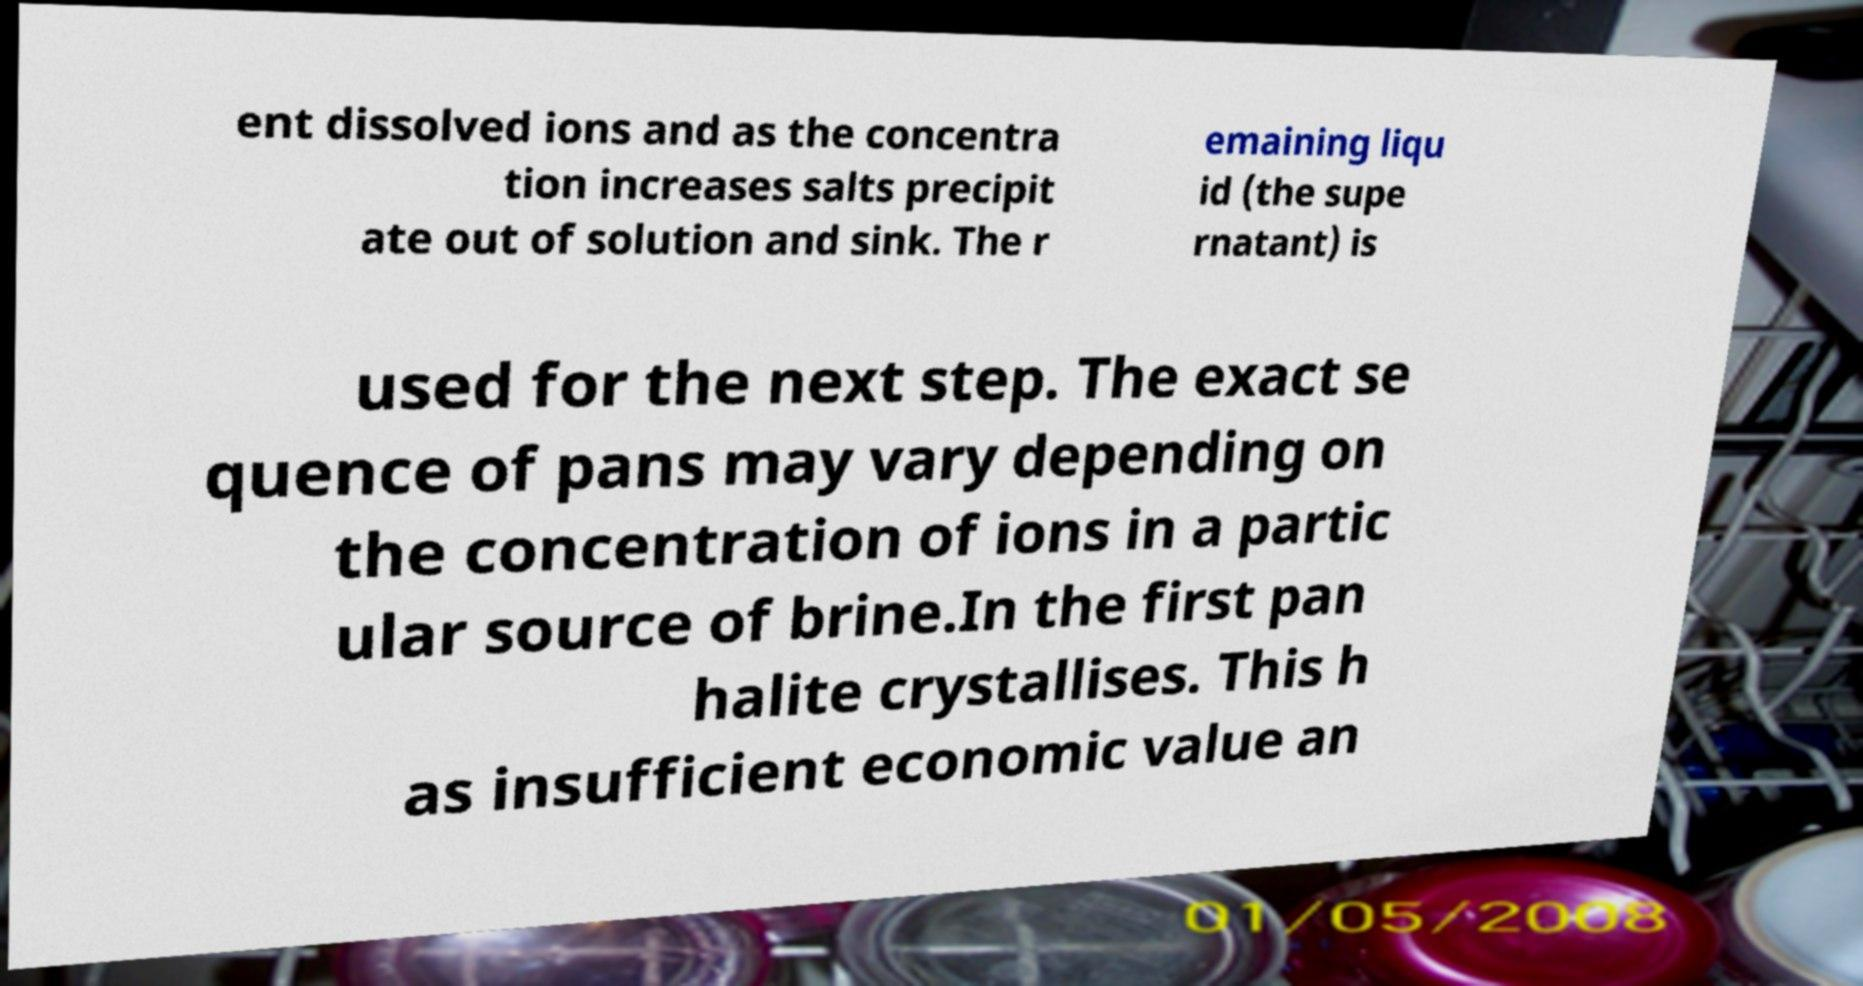Please read and relay the text visible in this image. What does it say? ent dissolved ions and as the concentra tion increases salts precipit ate out of solution and sink. The r emaining liqu id (the supe rnatant) is used for the next step. The exact se quence of pans may vary depending on the concentration of ions in a partic ular source of brine.In the first pan halite crystallises. This h as insufficient economic value an 